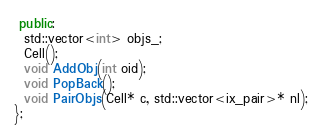Convert code to text. <code><loc_0><loc_0><loc_500><loc_500><_C++_> public:
  std::vector<int> objs_;
  Cell();
  void AddObj(int oid);
  void PopBack();
  void PairObjs(Cell* c, std::vector<ix_pair>* nl);
};
</code> 